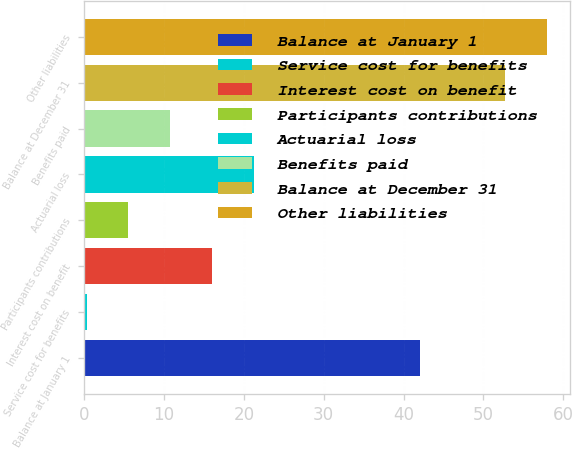Convert chart to OTSL. <chart><loc_0><loc_0><loc_500><loc_500><bar_chart><fcel>Balance at January 1<fcel>Service cost for benefits<fcel>Interest cost on benefit<fcel>Participants contributions<fcel>Actuarial loss<fcel>Benefits paid<fcel>Balance at December 31<fcel>Other liabilities<nl><fcel>42<fcel>0.3<fcel>16.02<fcel>5.54<fcel>21.26<fcel>10.78<fcel>52.7<fcel>57.94<nl></chart> 